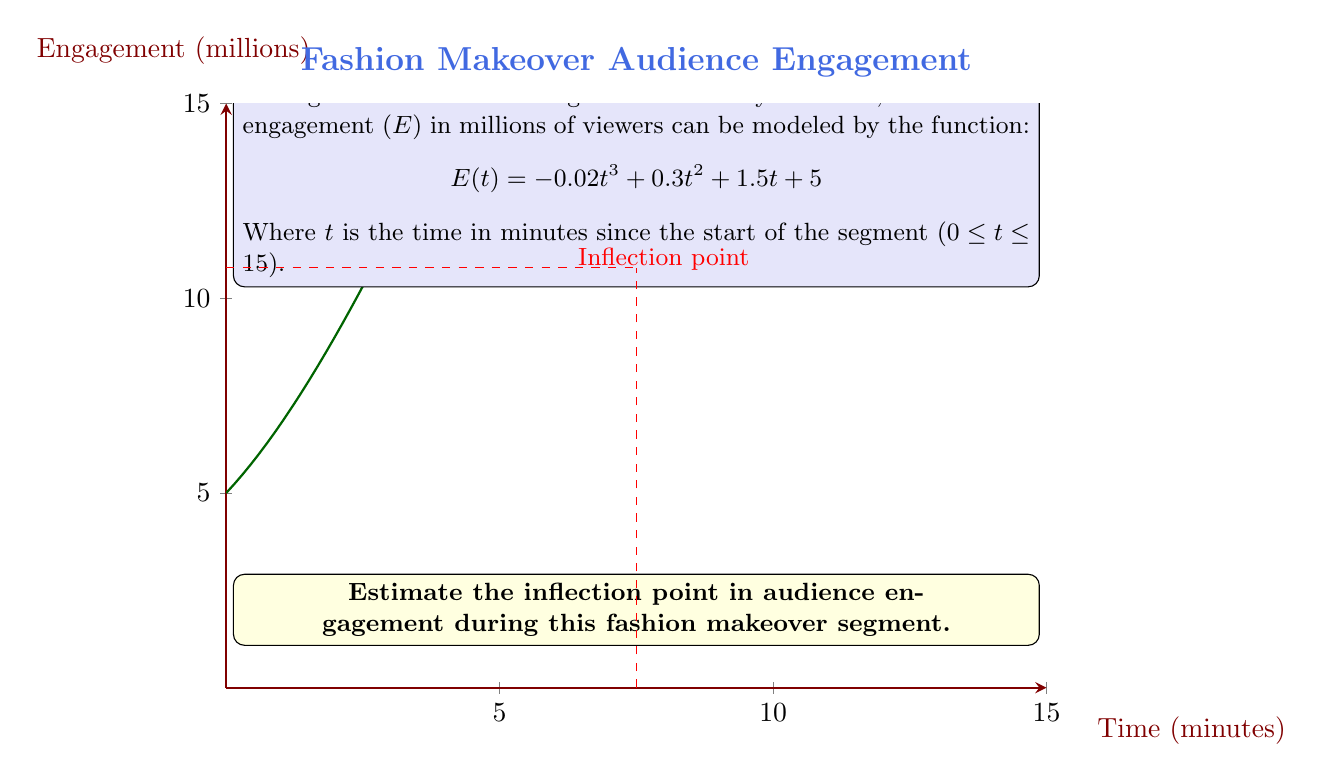What is the answer to this math problem? To find the inflection point, we need to follow these steps:

1) The inflection point occurs where the second derivative of E(t) equals zero.

2) First, let's find the first derivative:
   $$ E'(t) = -0.06t^2 + 0.6t + 1.5 $$

3) Now, let's find the second derivative:
   $$ E''(t) = -0.12t + 0.6 $$

4) Set the second derivative equal to zero and solve for t:
   $$ -0.12t + 0.6 = 0 $$
   $$ -0.12t = -0.6 $$
   $$ t = 5 $$

5) To confirm this is an inflection point, we can check that E''(t) changes sign at t = 5:
   E''(4) = 0.12 > 0
   E''(6) = -0.12 < 0

6) Now that we have the t-coordinate, let's find the corresponding E-coordinate:
   $$ E(5) = -0.02(5)^3 + 0.3(5)^2 + 1.5(5) + 5 $$
   $$ = -2.5 + 7.5 + 7.5 + 5 = 17.5 $$

Therefore, the inflection point occurs at (5, 17.5).
Answer: (5, 17.5) 